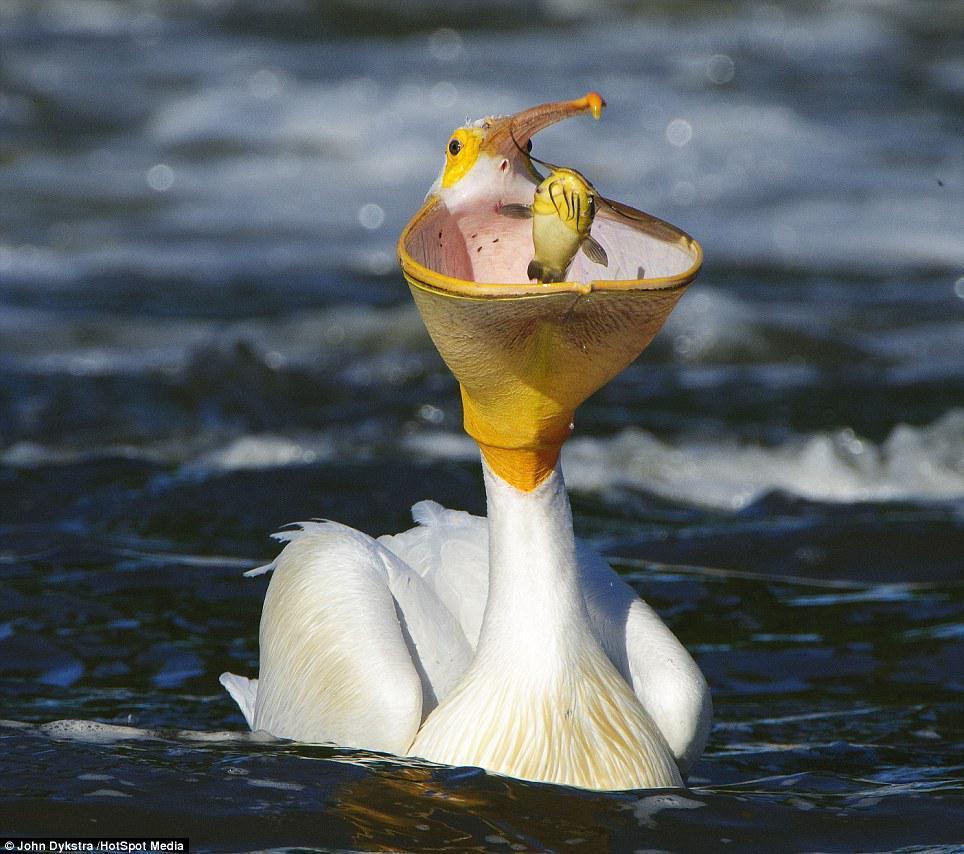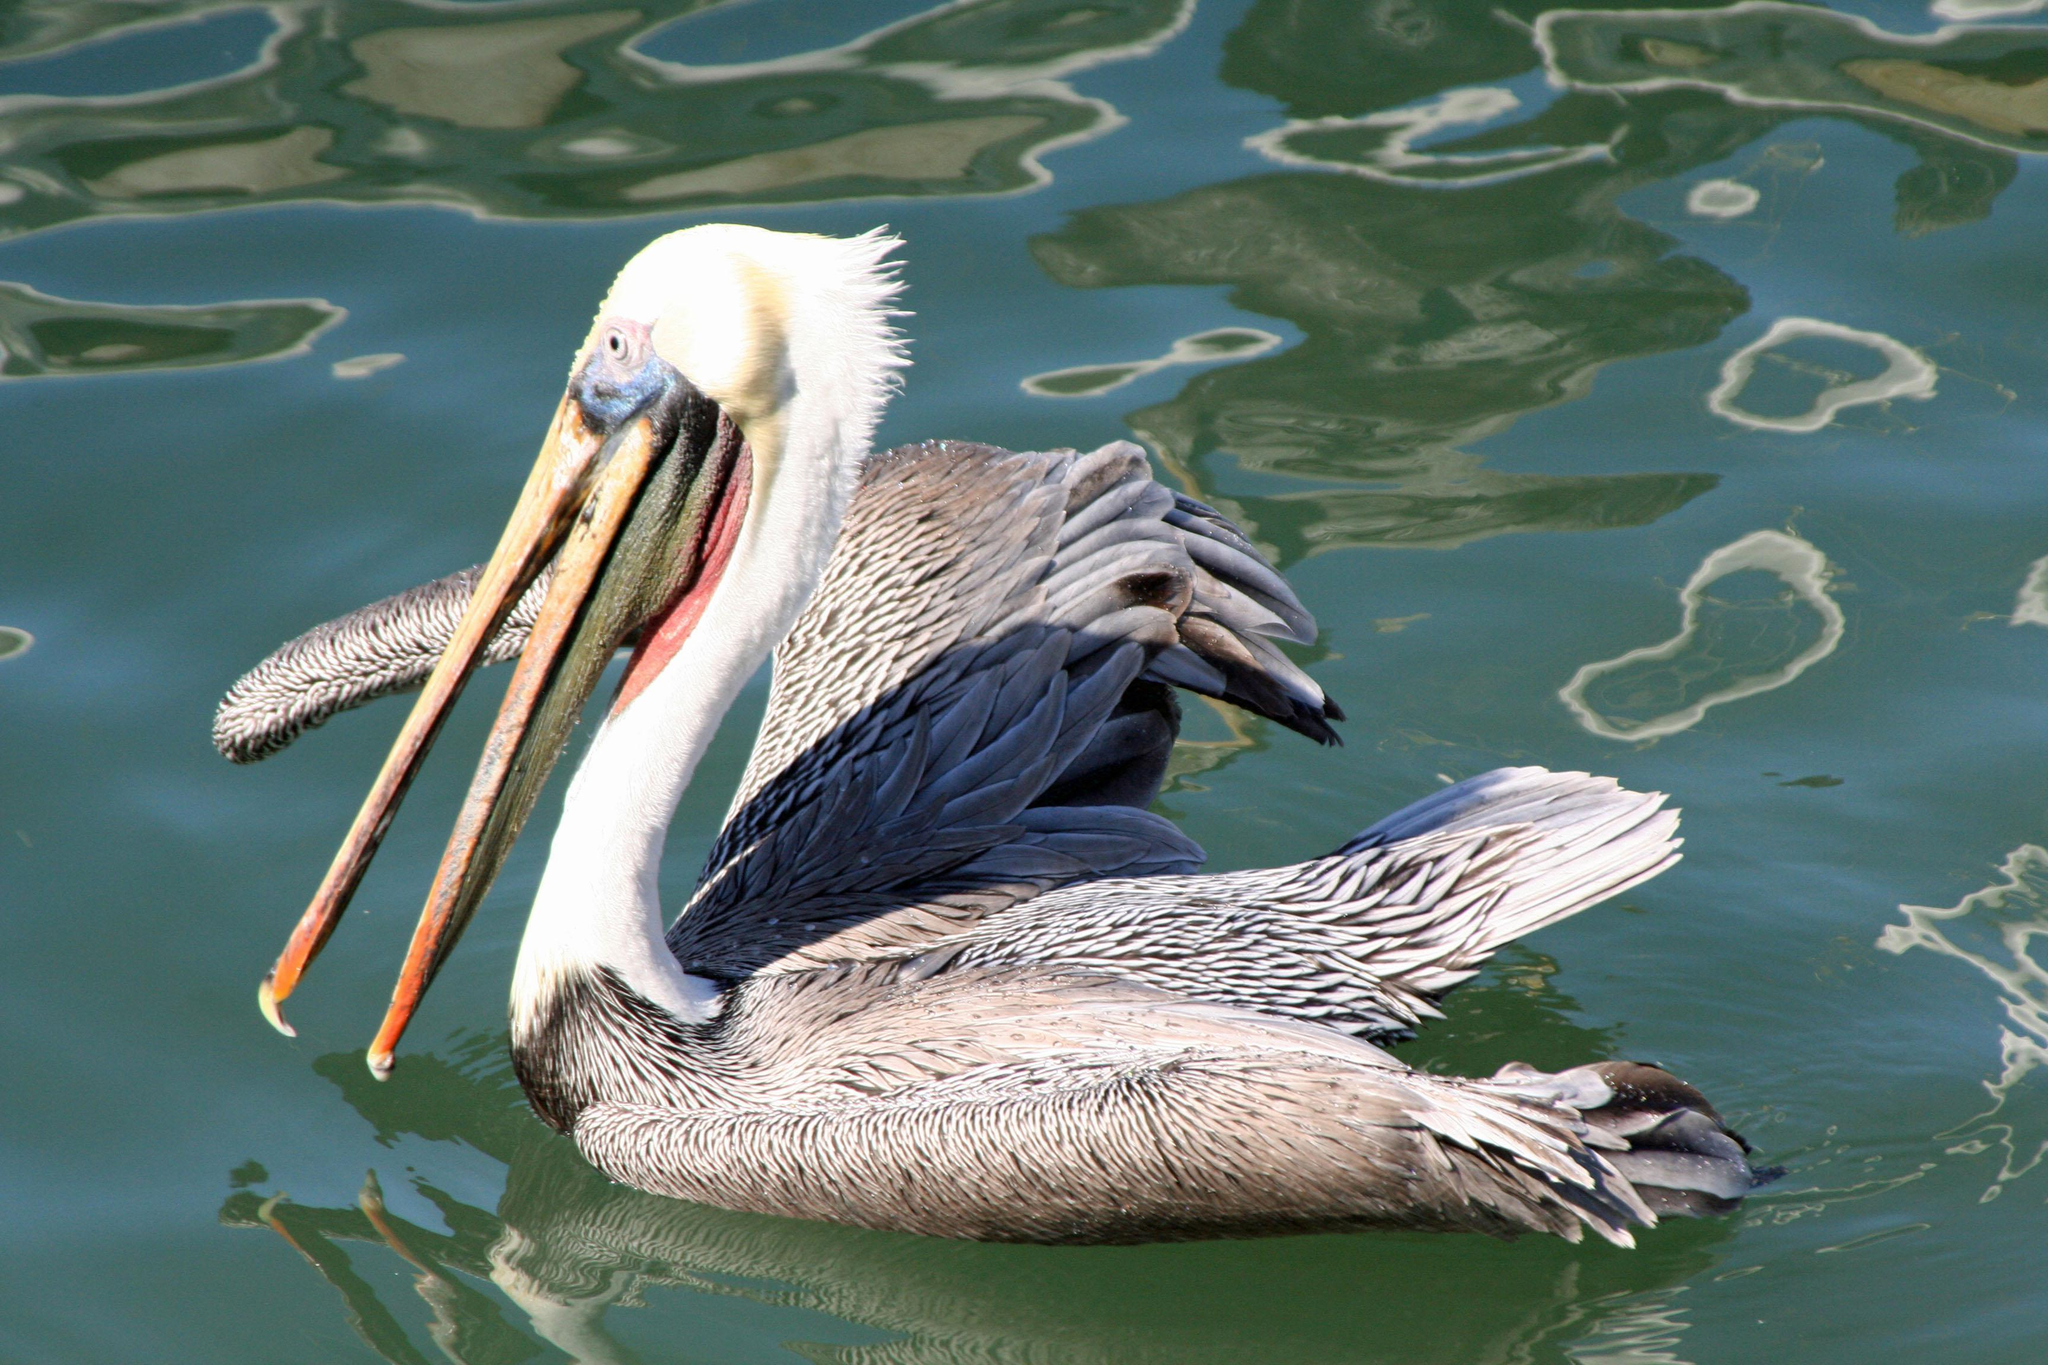The first image is the image on the left, the second image is the image on the right. Given the left and right images, does the statement "A fish is visible in the distended lower bill of a floating pelican with its body facing the camera." hold true? Answer yes or no. Yes. The first image is the image on the left, the second image is the image on the right. Considering the images on both sides, is "The bird in the image on the right is in flight." valid? Answer yes or no. No. The first image is the image on the left, the second image is the image on the right. For the images displayed, is the sentence "A bird flies right above the water in the image on the right." factually correct? Answer yes or no. No. The first image is the image on the left, the second image is the image on the right. For the images shown, is this caption "One white-bodied pelican has a closed beak and is in the air above the water with spread wings." true? Answer yes or no. No. 